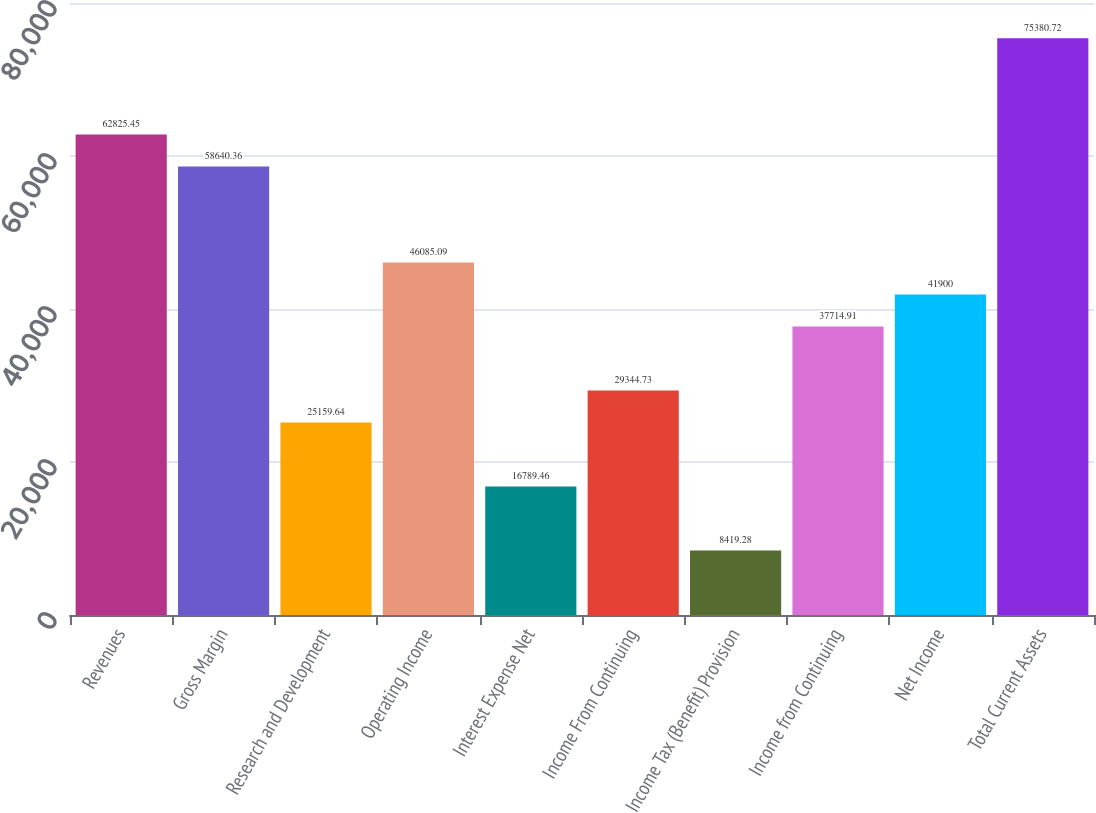<chart> <loc_0><loc_0><loc_500><loc_500><bar_chart><fcel>Revenues<fcel>Gross Margin<fcel>Research and Development<fcel>Operating Income<fcel>Interest Expense Net<fcel>Income From Continuing<fcel>Income Tax (Benefit) Provision<fcel>Income from Continuing<fcel>Net Income<fcel>Total Current Assets<nl><fcel>62825.4<fcel>58640.4<fcel>25159.6<fcel>46085.1<fcel>16789.5<fcel>29344.7<fcel>8419.28<fcel>37714.9<fcel>41900<fcel>75380.7<nl></chart> 